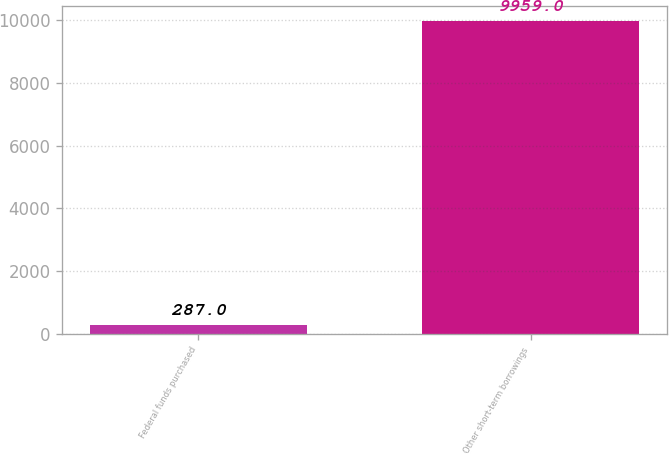<chart> <loc_0><loc_0><loc_500><loc_500><bar_chart><fcel>Federal funds purchased<fcel>Other short-term borrowings<nl><fcel>287<fcel>9959<nl></chart> 